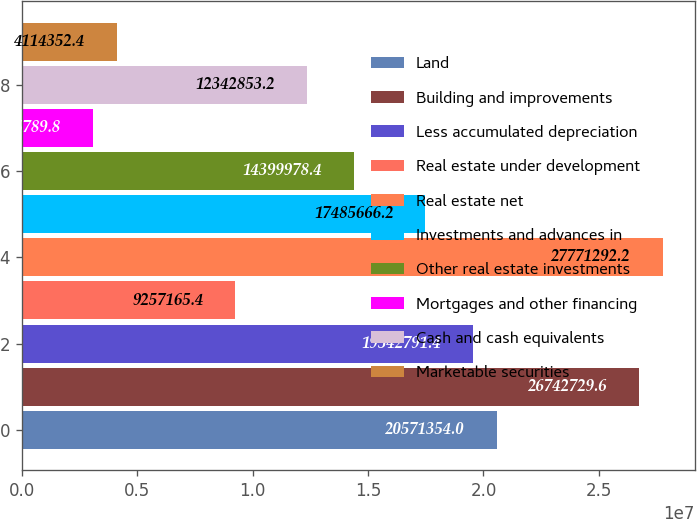Convert chart. <chart><loc_0><loc_0><loc_500><loc_500><bar_chart><fcel>Land<fcel>Building and improvements<fcel>Less accumulated depreciation<fcel>Real estate under development<fcel>Real estate net<fcel>Investments and advances in<fcel>Other real estate investments<fcel>Mortgages and other financing<fcel>Cash and cash equivalents<fcel>Marketable securities<nl><fcel>2.05714e+07<fcel>2.67427e+07<fcel>1.95428e+07<fcel>9.25717e+06<fcel>2.77713e+07<fcel>1.74857e+07<fcel>1.44e+07<fcel>3.08579e+06<fcel>1.23429e+07<fcel>4.11435e+06<nl></chart> 